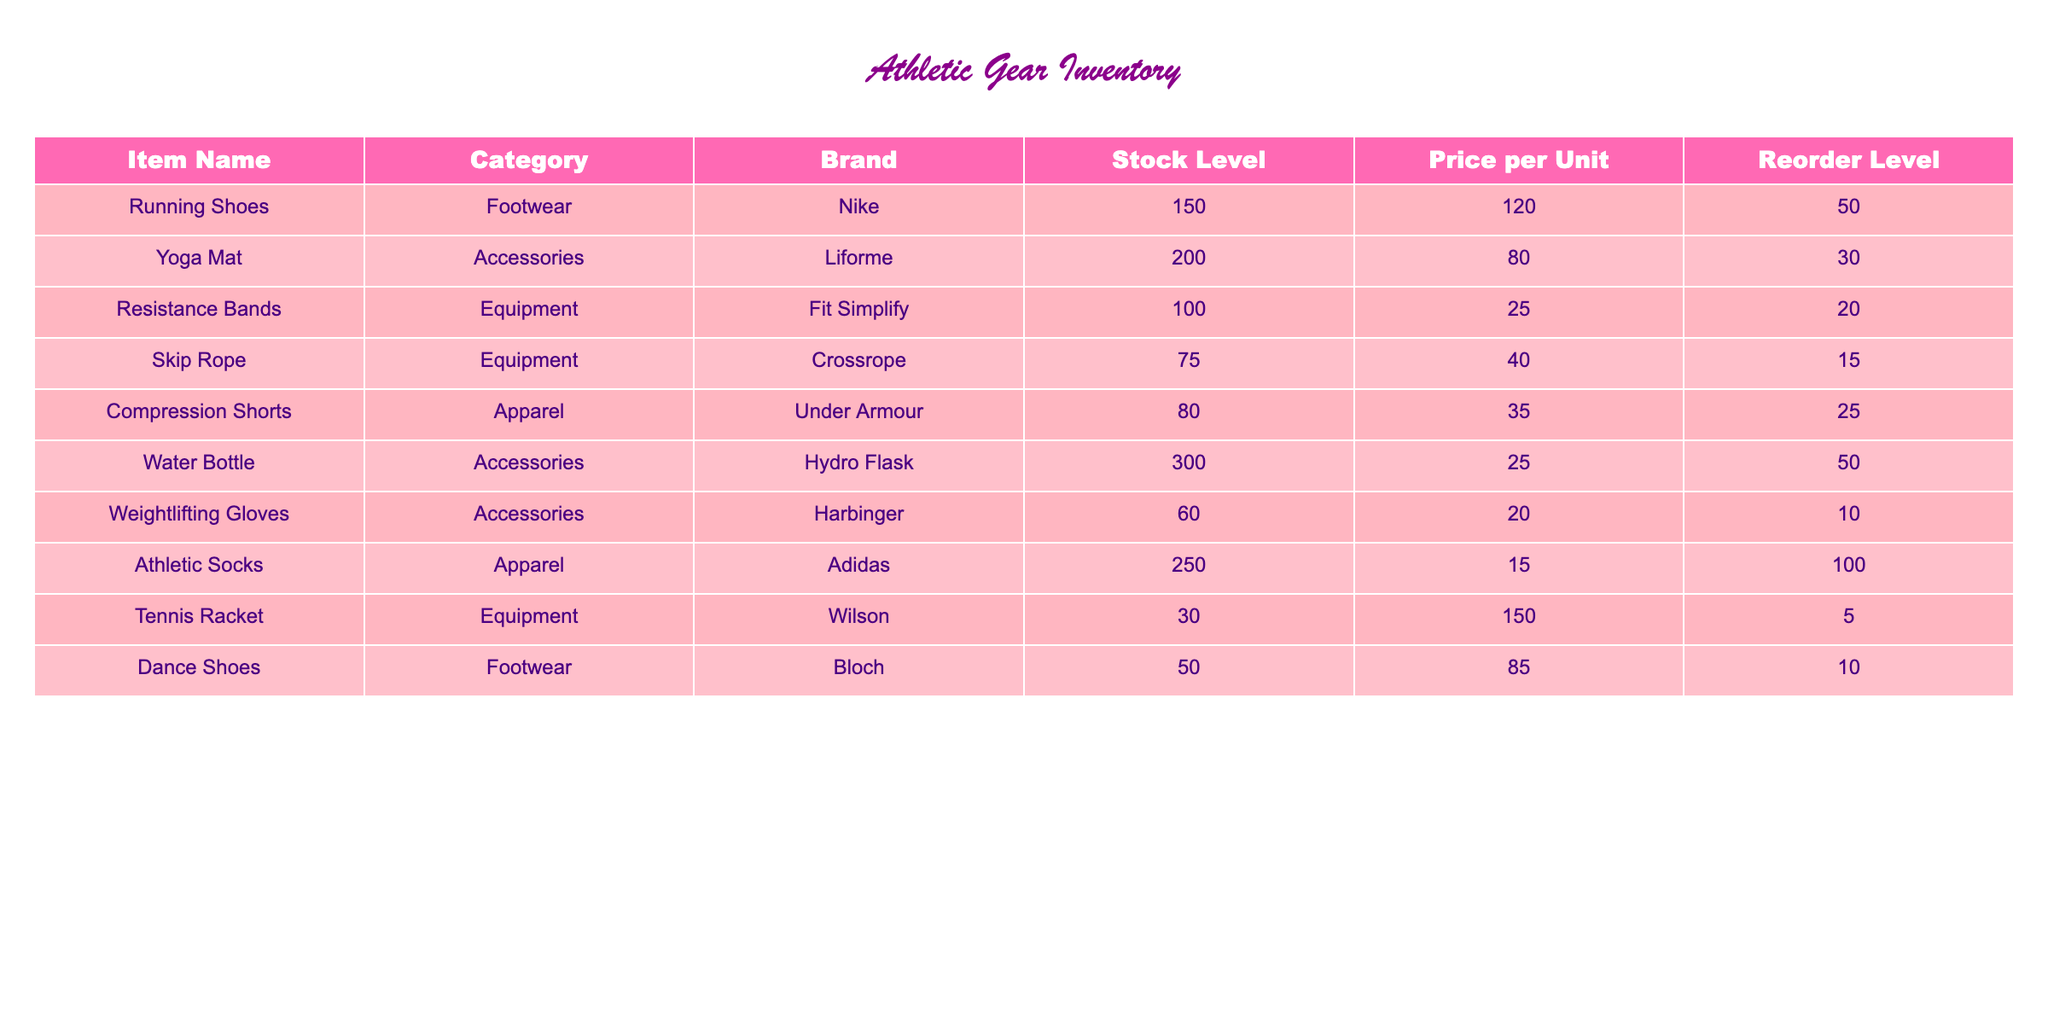What is the stock level of Resistance Bands? The table lists the stock level of Resistance Bands under the "Stock Level" column, where it shows a value of 100.
Answer: 100 What brand makes the Athletic Socks? Looking at the table, the brand associated with Athletic Socks is Adidas, as indicated in the "Brand" column for that item.
Answer: Adidas Is the stock level of Dance Shoes below the reorder level? To determine this, I check that the stock level for Dance Shoes is 50, and the reorder level is 10. Since 50 is above 10, the statement is false.
Answer: No What is the total stock level of all Footwear items? The two footwear items are Running Shoes (150) and Dance Shoes (50). Adding these together gives: 150 + 50 = 200.
Answer: 200 Does the Water Bottle have a higher stock level than the average stock level of all items listed? First, I find the total stock levels of all items: 150 + 200 + 100 + 75 + 80 + 300 + 60 + 250 + 30 + 50 = 1095. There are 10 items, so the average is 1095 / 10 = 109.5. Since the Water Bottle stock level is 300, which is higher than 109.5, it's true.
Answer: Yes Which item has the highest price per unit? The table lists prices, and by examining the "Price per Unit" column, the highest price is 150.00 for the Tennis Racket.
Answer: Tennis Racket What is the combined price of Yoga Mats and Compression Shorts? The price of Yoga Mats is 80.00 and Compression Shorts is 35.00. Adding these values gives: 80.00 + 35.00 = 115.00.
Answer: 115.00 Which category has the lowest stock level? I check each category's items: Footwear (200), Accessories (360), Equipment (175), and Apparel (330). The lowest is Footwear, with a total stock level of 200.
Answer: Footwear How many more Weightlifting Gloves do we need to reach the reorder level? The current stock level of Weightlifting Gloves is 60, and the reorder level is 10. Since it is above the reorder level, no additional gloves are needed.
Answer: 0 